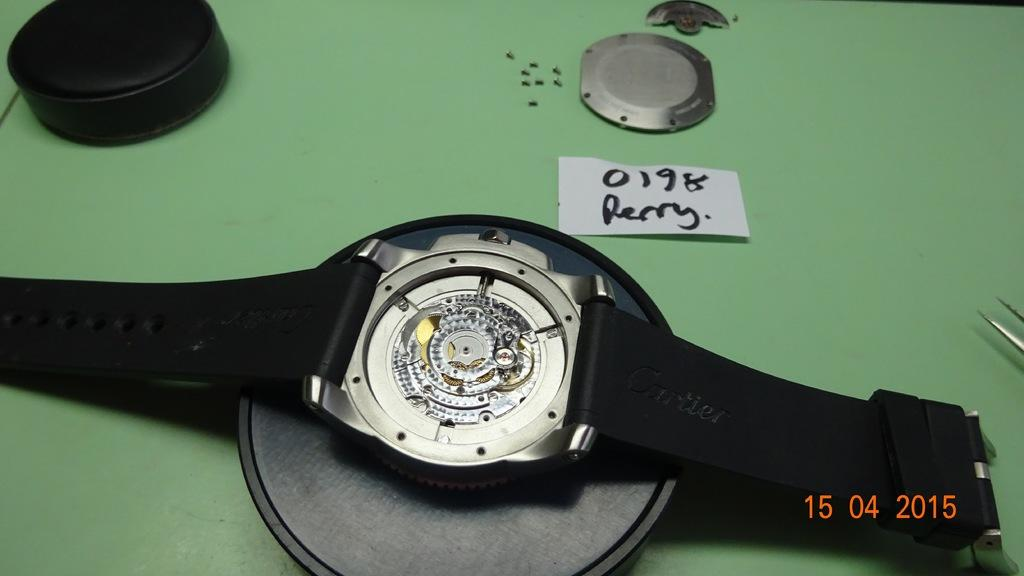<image>
Relay a brief, clear account of the picture shown. A Perry watch model number 0198 is being worked on in 2015 